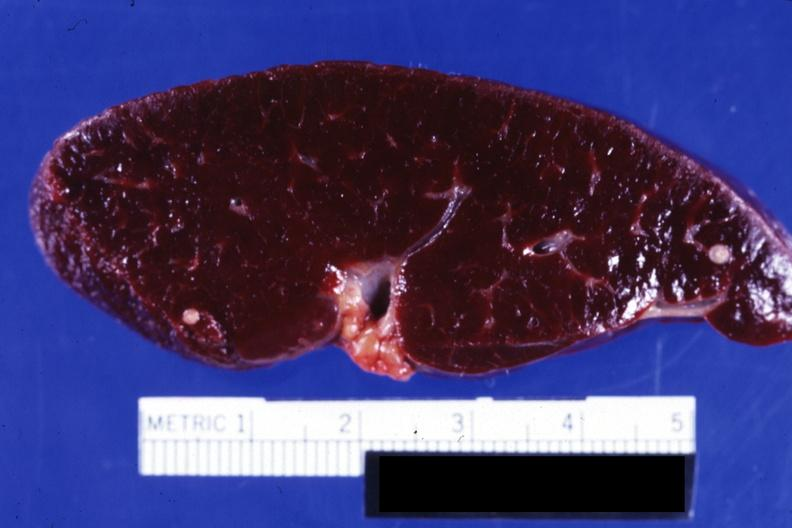does feet show close-up of cut surface showing two typical old granulomas?
Answer the question using a single word or phrase. No 